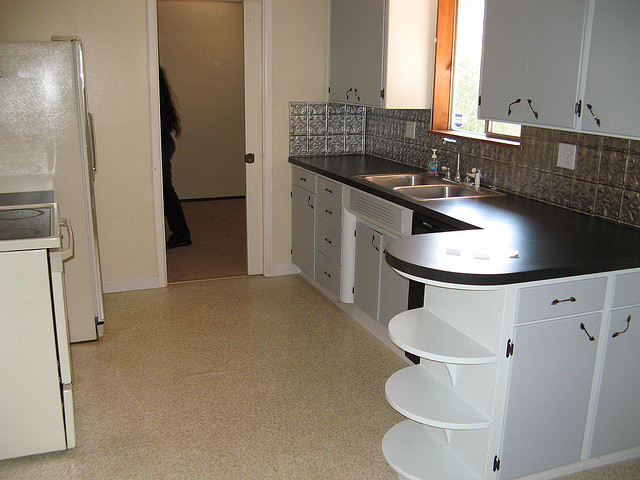<image>What is the black splash made of? I don't know what the black splash is made of. It can be tile, wood, aluminum, metal or paint. What is the black splash made of? I don't know what the black splash is made of. It can be made of tile, wood, aluminum, metal or paint. 